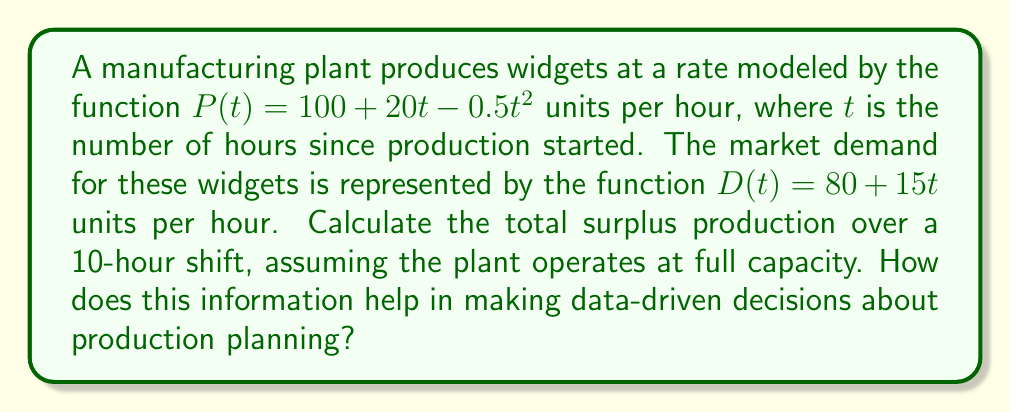Solve this math problem. To solve this problem, we need to follow these steps:

1) The surplus production at any given time $t$ is the difference between production and demand:
   $S(t) = P(t) - D(t) = (100 + 20t - 0.5t^2) - (80 + 15t) = 20 + 5t - 0.5t^2$

2) To find the total surplus over the 10-hour shift, we need to integrate $S(t)$ from $t=0$ to $t=10$:

   $$\int_0^{10} S(t) dt = \int_0^{10} (20 + 5t - 0.5t^2) dt$$

3) Integrate each term:
   $$\int_0^{10} 20 dt + \int_0^{10} 5t dt - \int_0^{10} 0.5t^2 dt$$
   
   $$= [20t]_0^{10} + [2.5t^2]_0^{10} - [\frac{1}{6}t^3]_0^{10}$$

4) Evaluate the definite integral:
   $$(200 - 0) + (250 - 0) - (\frac{1000}{6} - 0) = 450 - \frac{1000}{6} = 283.33$$

5) The result, 283.33 units, represents the total surplus production over the 10-hour shift.

This information helps in making data-driven decisions about production planning by:
- Quantifying overproduction, which ties up capital in inventory
- Identifying potential waste in the production process
- Highlighting the need for better alignment between production capacity and market demand
- Providing a basis for adjusting production rates or shift durations to optimize efficiency
Answer: 283.33 units 